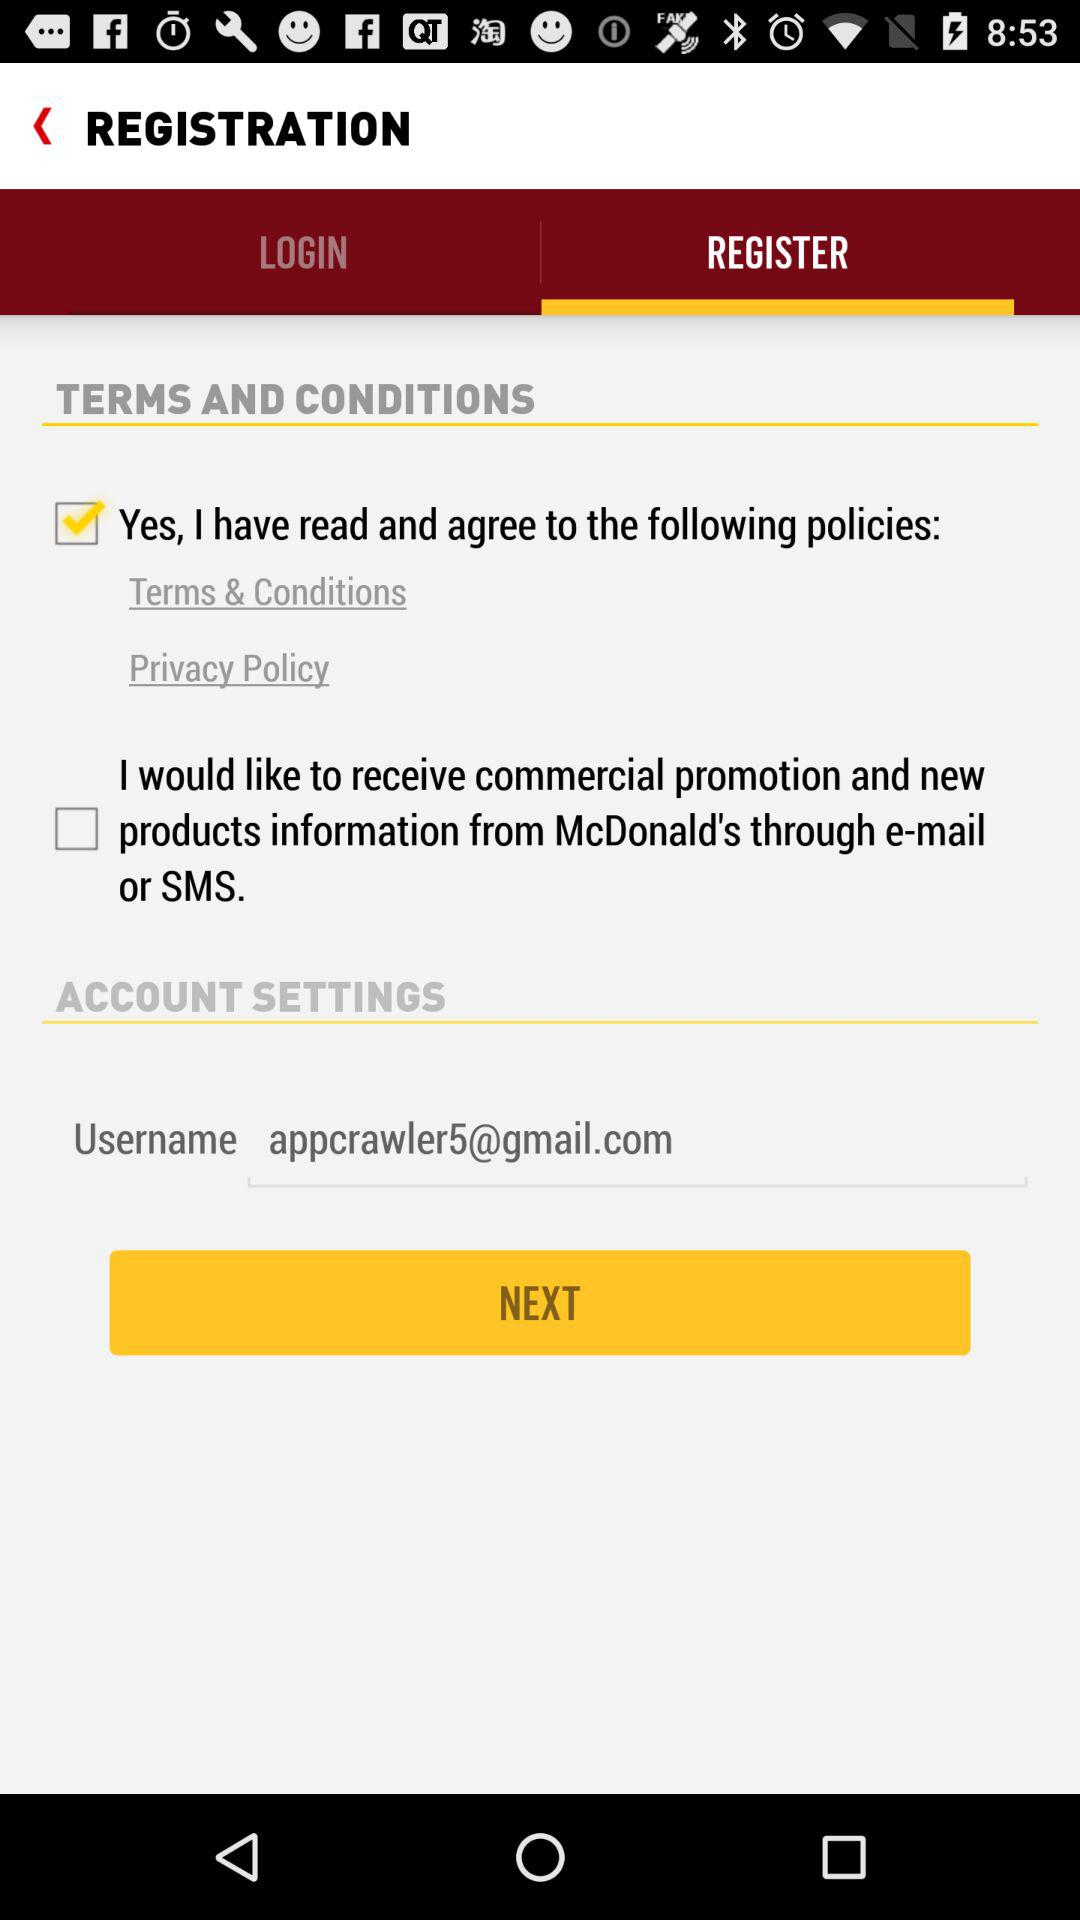What is the username? The username is "appcrawler5@gmail.com". 